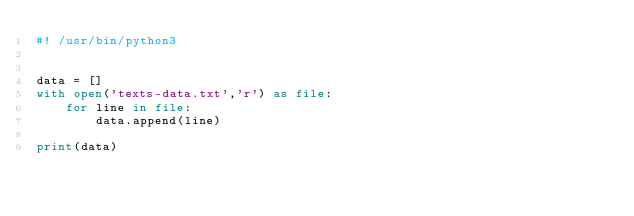Convert code to text. <code><loc_0><loc_0><loc_500><loc_500><_Python_>#! /usr/bin/python3


data = []
with open('texts-data.txt','r') as file:
    for line in file:
        data.append(line)

print(data)
</code> 